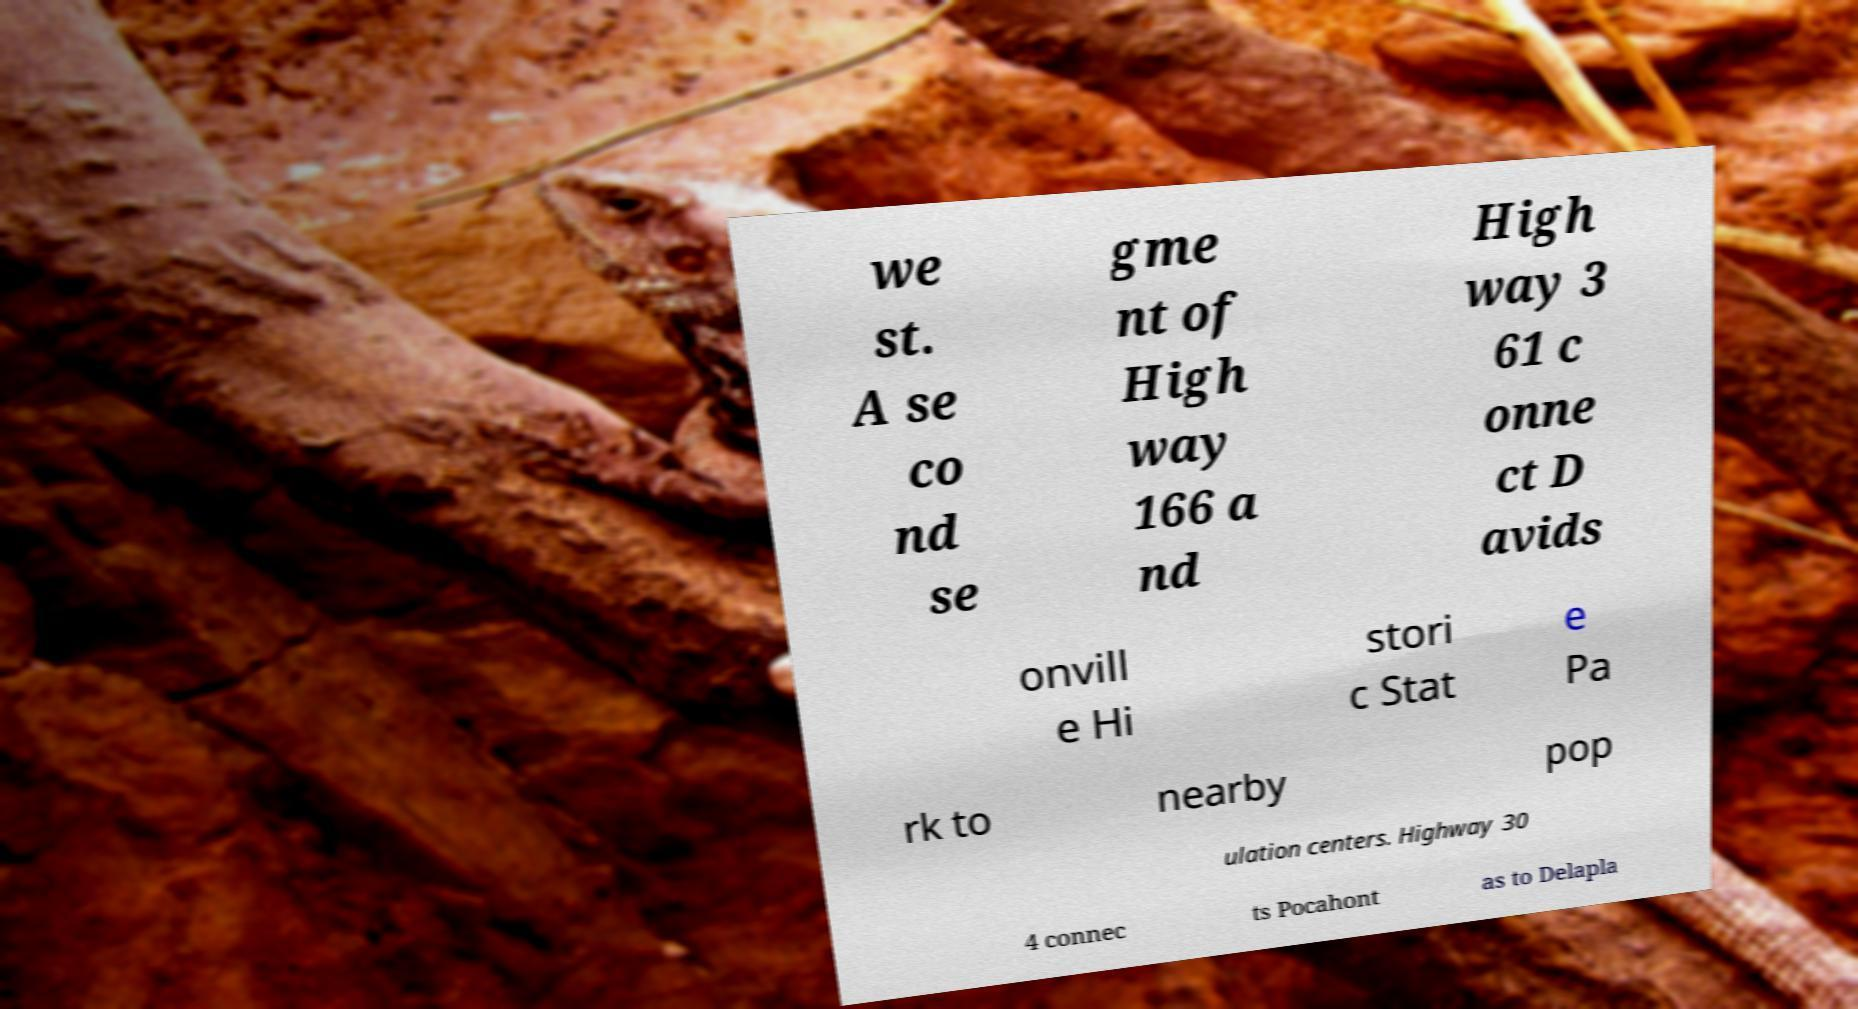Can you accurately transcribe the text from the provided image for me? we st. A se co nd se gme nt of High way 166 a nd High way 3 61 c onne ct D avids onvill e Hi stori c Stat e Pa rk to nearby pop ulation centers. Highway 30 4 connec ts Pocahont as to Delapla 